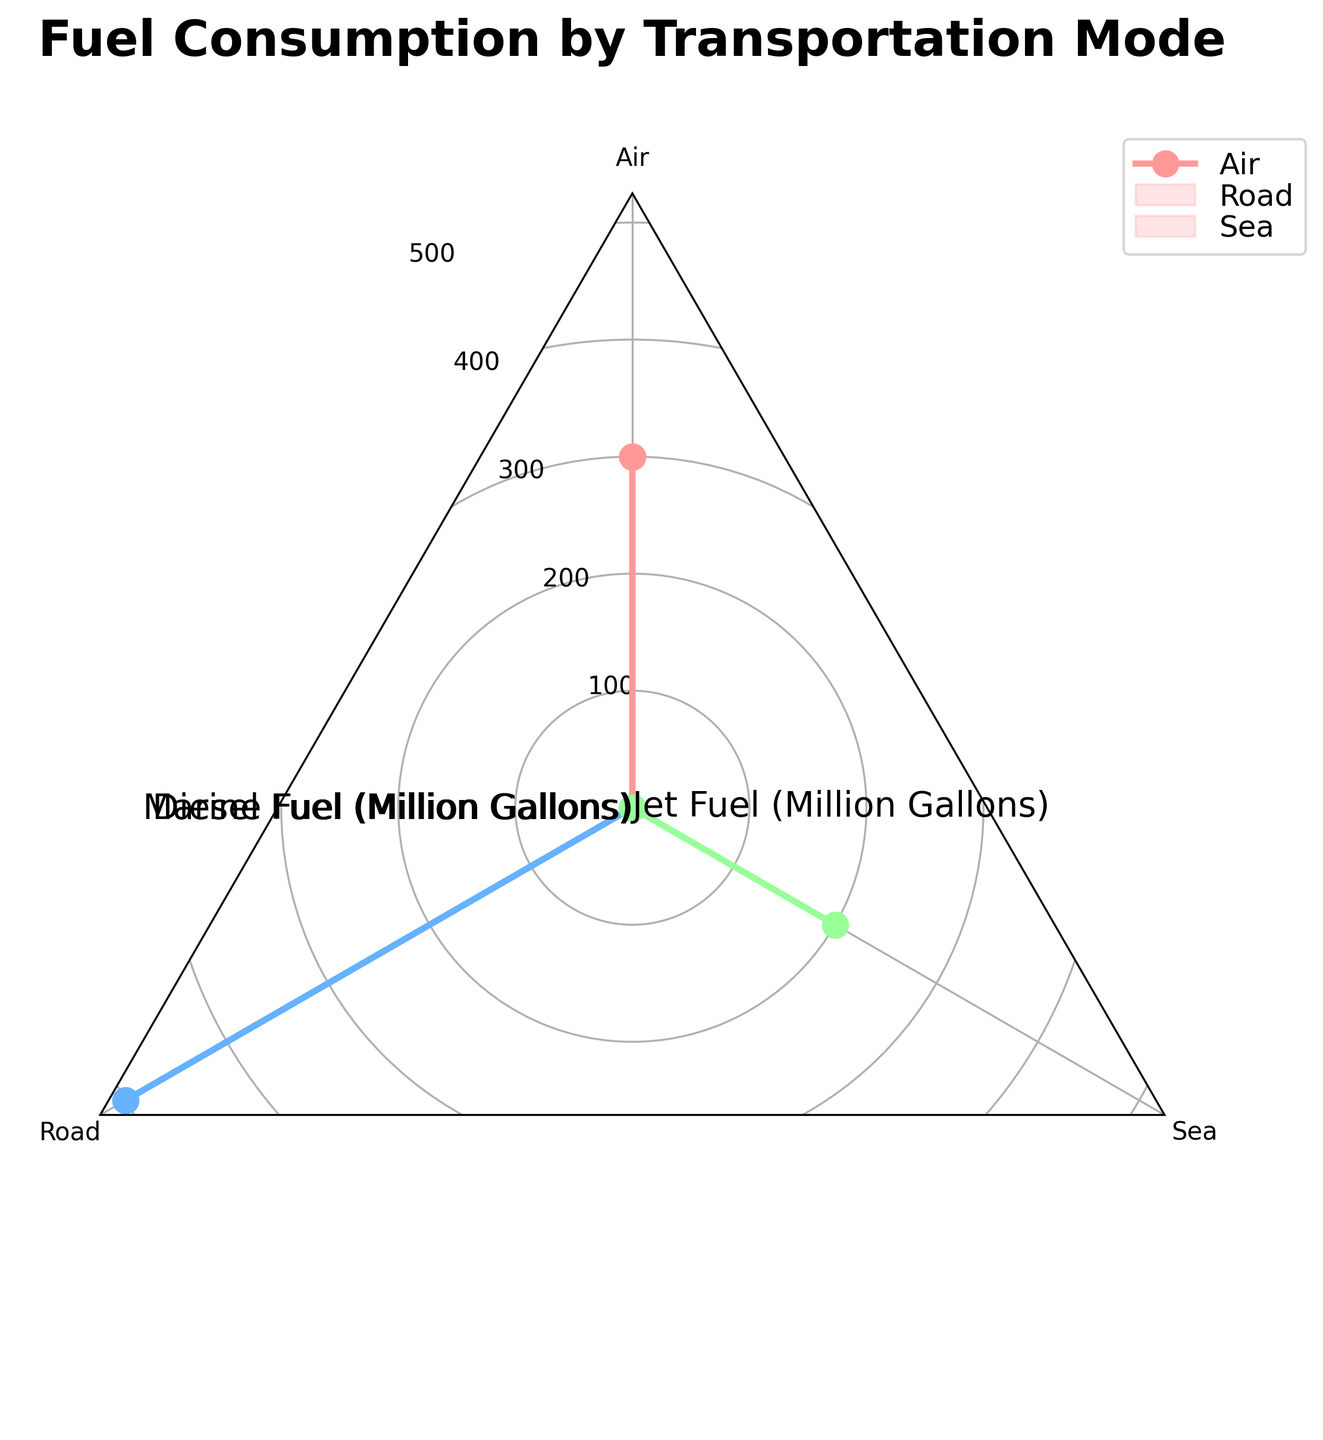What is the title of the radar chart? The title of the radar chart is positioned at the top and provides an overview of what the chart represents.
Answer: Fuel Consumption by Transportation Mode How many transportation modes are shown in the radar chart? The radar chart has distinct sections and labels representing each transportation mode.
Answer: Three What color represents the 'Air' transportation mode? Each transportation mode is represented by a unique color. By matching the labels on the chart to the corresponding color, you can identify the color for 'Air'.
Answer: Red Which transportation mode consumes the most diesel fuel? Look at the spoke labeled 'Diesel Fuel' and compare the values for each transportation mode. The mode with the highest point on this spoke consumes the most diesel fuel.
Answer: Road Does the 'Sea' transportation mode consume any diesel fuel? By examining the 'Diesel Fuel' spoke, observe if there is any value plotted for the 'Sea' mode.
Answer: No What is the difference between the diesel fuel consumed by 'Road' and 'Air' modes? Locate the points for 'Road' and 'Air' on the 'Diesel Fuel' spoke and compute the difference between values.
Answer: 500 million gallons Which transportation mode uses the highest total amount of fuel? Calculate the total fuel consumption for each mode by summing the respective values on each spoke. Compare these totals to find the highest.
Answer: Air (300 million gallons of Jet Fuel) Which transportation mode uses marine fuel, and how much is consumed? Locate the 'Marine Fuel' spoke and identify the transportation mode with a non-zero value. Read off the amount consumed.
Answer: Sea: 200 million gallons How does the 'Air' mode's jet fuel consumption compare to the 'Sea' mode's marine fuel consumption? Compare the values of jet fuel consumption for 'Air' and marine fuel consumption for 'Sea' by looking at their positions on the respective spokes.
Answer: Air consumes 100 million gallons more What is the average fuel consumption per mode for the given data? Sum all fuel consumption values and divide by the number of modes (3).
Answer: (300 + 500 + 200)/3 = 333.33 million gallons Are any of the transportation modes using more than one type of fuel? Check each transportation mode and see if more than one spoke has a non-zero value.
Answer: No 